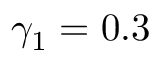Convert formula to latex. <formula><loc_0><loc_0><loc_500><loc_500>\gamma _ { 1 } = 0 . 3</formula> 